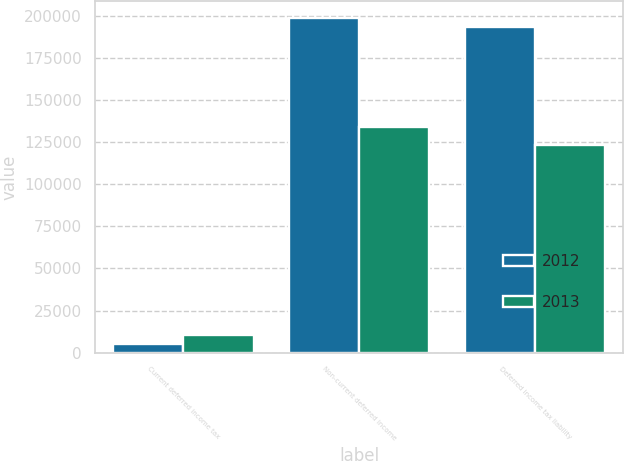<chart> <loc_0><loc_0><loc_500><loc_500><stacked_bar_chart><ecel><fcel>Current deferred income tax<fcel>Non-current deferred income<fcel>Deferred income tax liability<nl><fcel>2012<fcel>5077<fcel>198604<fcel>193527<nl><fcel>2013<fcel>10397<fcel>133761<fcel>123364<nl></chart> 